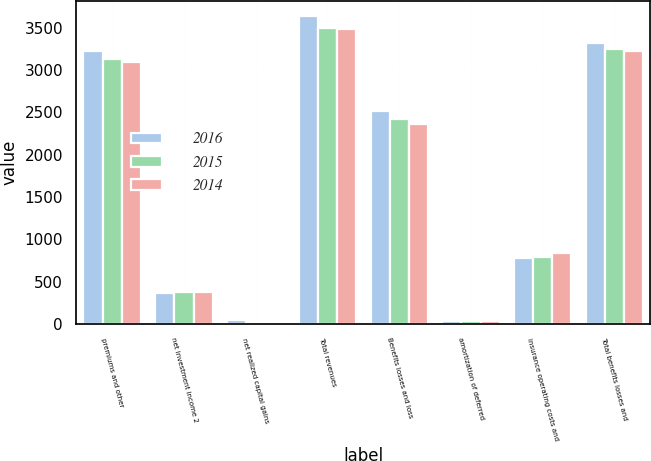Convert chart to OTSL. <chart><loc_0><loc_0><loc_500><loc_500><stacked_bar_chart><ecel><fcel>premiums and other<fcel>net investment income 2<fcel>net realized capital gains<fcel>Total revenues<fcel>Benefits losses and loss<fcel>amortization of deferred<fcel>insurance operating costs and<fcel>Total benefits losses and<nl><fcel>2016<fcel>3223<fcel>366<fcel>45<fcel>3634<fcel>2514<fcel>31<fcel>776<fcel>3321<nl><fcel>2015<fcel>3136<fcel>371<fcel>11<fcel>3496<fcel>2427<fcel>31<fcel>788<fcel>3246<nl><fcel>2014<fcel>3095<fcel>374<fcel>15<fcel>3484<fcel>2362<fcel>32<fcel>836<fcel>3230<nl></chart> 